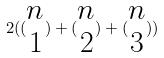<formula> <loc_0><loc_0><loc_500><loc_500>2 ( ( \begin{matrix} n \\ 1 \end{matrix} ) + ( \begin{matrix} n \\ 2 \end{matrix} ) + ( \begin{matrix} n \\ 3 \end{matrix} ) )</formula> 